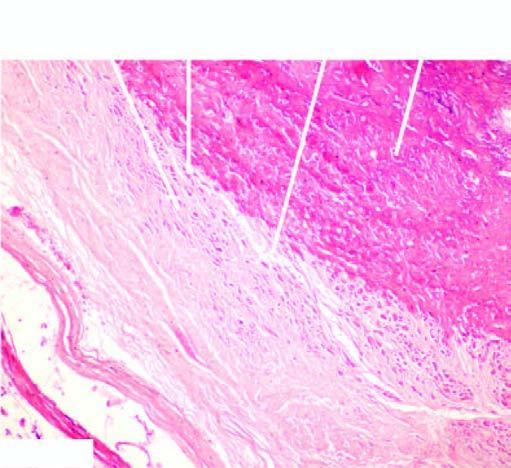what show osseous metaplasia in the centre?
Answer the question using a single word or phrase. Whorls composed of smooth muscle cells and fibroblasts 